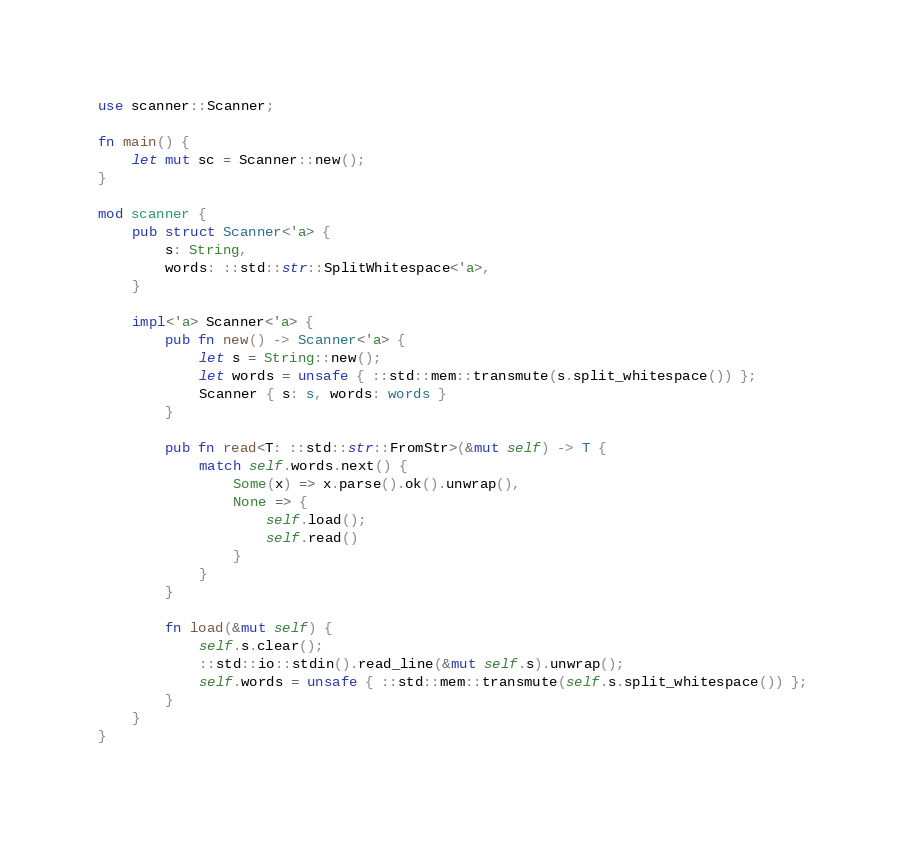<code> <loc_0><loc_0><loc_500><loc_500><_Rust_>use scanner::Scanner;

fn main() {
    let mut sc = Scanner::new();
}

mod scanner {
    pub struct Scanner<'a> {
        s: String,
        words: ::std::str::SplitWhitespace<'a>,
    }

    impl<'a> Scanner<'a> {
        pub fn new() -> Scanner<'a> {
            let s = String::new();
            let words = unsafe { ::std::mem::transmute(s.split_whitespace()) };
            Scanner { s: s, words: words }
        }

        pub fn read<T: ::std::str::FromStr>(&mut self) -> T {
            match self.words.next() {
                Some(x) => x.parse().ok().unwrap(),
                None => {
                    self.load();
                    self.read()
                }
            }
        }

        fn load(&mut self) {
            self.s.clear();
            ::std::io::stdin().read_line(&mut self.s).unwrap();
            self.words = unsafe { ::std::mem::transmute(self.s.split_whitespace()) };
        }
    }
}</code> 